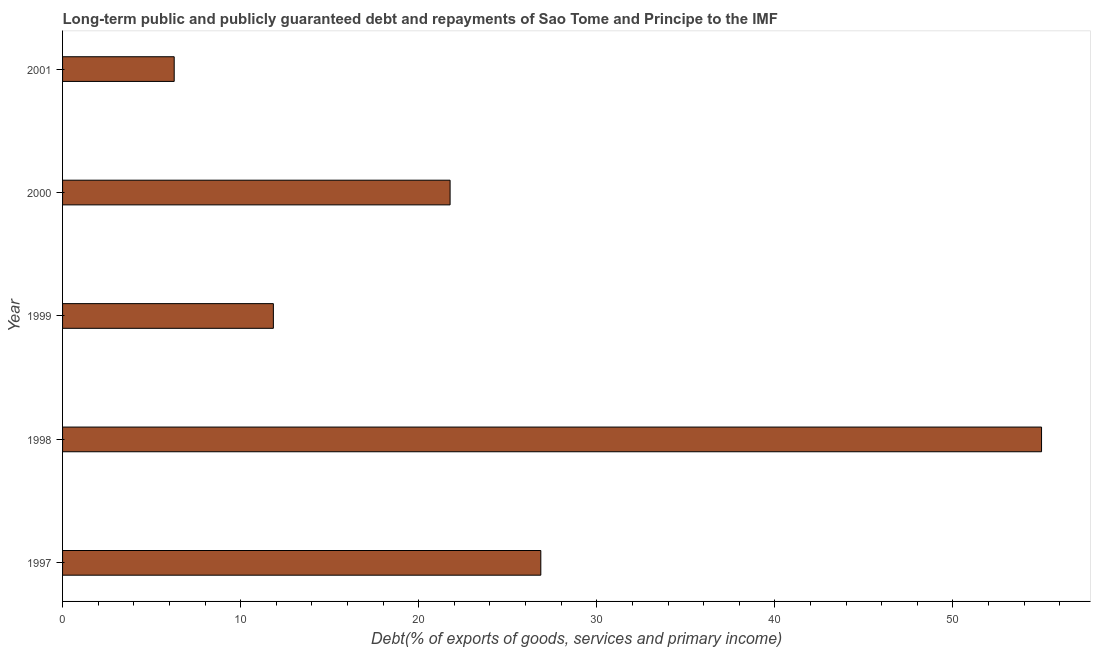Does the graph contain any zero values?
Provide a succinct answer. No. Does the graph contain grids?
Your answer should be compact. No. What is the title of the graph?
Keep it short and to the point. Long-term public and publicly guaranteed debt and repayments of Sao Tome and Principe to the IMF. What is the label or title of the X-axis?
Your answer should be compact. Debt(% of exports of goods, services and primary income). What is the debt service in 1999?
Make the answer very short. 11.84. Across all years, what is the maximum debt service?
Make the answer very short. 54.97. Across all years, what is the minimum debt service?
Your response must be concise. 6.27. In which year was the debt service maximum?
Ensure brevity in your answer.  1998. In which year was the debt service minimum?
Make the answer very short. 2001. What is the sum of the debt service?
Ensure brevity in your answer.  121.7. What is the difference between the debt service in 1997 and 1998?
Keep it short and to the point. -28.12. What is the average debt service per year?
Make the answer very short. 24.34. What is the median debt service?
Offer a very short reply. 21.76. In how many years, is the debt service greater than 34 %?
Provide a short and direct response. 1. Do a majority of the years between 1998 and 2001 (inclusive) have debt service greater than 6 %?
Provide a succinct answer. Yes. What is the ratio of the debt service in 1998 to that in 2001?
Your answer should be very brief. 8.77. What is the difference between the highest and the second highest debt service?
Offer a very short reply. 28.12. Is the sum of the debt service in 1998 and 1999 greater than the maximum debt service across all years?
Offer a terse response. Yes. What is the difference between the highest and the lowest debt service?
Keep it short and to the point. 48.71. In how many years, is the debt service greater than the average debt service taken over all years?
Offer a very short reply. 2. Are all the bars in the graph horizontal?
Your answer should be compact. Yes. How many years are there in the graph?
Give a very brief answer. 5. What is the difference between two consecutive major ticks on the X-axis?
Keep it short and to the point. 10. Are the values on the major ticks of X-axis written in scientific E-notation?
Keep it short and to the point. No. What is the Debt(% of exports of goods, services and primary income) in 1997?
Offer a terse response. 26.86. What is the Debt(% of exports of goods, services and primary income) in 1998?
Provide a short and direct response. 54.97. What is the Debt(% of exports of goods, services and primary income) in 1999?
Your answer should be very brief. 11.84. What is the Debt(% of exports of goods, services and primary income) of 2000?
Give a very brief answer. 21.76. What is the Debt(% of exports of goods, services and primary income) of 2001?
Offer a terse response. 6.27. What is the difference between the Debt(% of exports of goods, services and primary income) in 1997 and 1998?
Your answer should be very brief. -28.12. What is the difference between the Debt(% of exports of goods, services and primary income) in 1997 and 1999?
Offer a very short reply. 15.02. What is the difference between the Debt(% of exports of goods, services and primary income) in 1997 and 2000?
Ensure brevity in your answer.  5.09. What is the difference between the Debt(% of exports of goods, services and primary income) in 1997 and 2001?
Your response must be concise. 20.59. What is the difference between the Debt(% of exports of goods, services and primary income) in 1998 and 1999?
Your answer should be very brief. 43.14. What is the difference between the Debt(% of exports of goods, services and primary income) in 1998 and 2000?
Give a very brief answer. 33.21. What is the difference between the Debt(% of exports of goods, services and primary income) in 1998 and 2001?
Ensure brevity in your answer.  48.71. What is the difference between the Debt(% of exports of goods, services and primary income) in 1999 and 2000?
Give a very brief answer. -9.92. What is the difference between the Debt(% of exports of goods, services and primary income) in 1999 and 2001?
Offer a very short reply. 5.57. What is the difference between the Debt(% of exports of goods, services and primary income) in 2000 and 2001?
Your answer should be very brief. 15.49. What is the ratio of the Debt(% of exports of goods, services and primary income) in 1997 to that in 1998?
Offer a terse response. 0.49. What is the ratio of the Debt(% of exports of goods, services and primary income) in 1997 to that in 1999?
Your answer should be very brief. 2.27. What is the ratio of the Debt(% of exports of goods, services and primary income) in 1997 to that in 2000?
Offer a very short reply. 1.23. What is the ratio of the Debt(% of exports of goods, services and primary income) in 1997 to that in 2001?
Offer a very short reply. 4.28. What is the ratio of the Debt(% of exports of goods, services and primary income) in 1998 to that in 1999?
Your answer should be very brief. 4.64. What is the ratio of the Debt(% of exports of goods, services and primary income) in 1998 to that in 2000?
Give a very brief answer. 2.53. What is the ratio of the Debt(% of exports of goods, services and primary income) in 1998 to that in 2001?
Your answer should be compact. 8.77. What is the ratio of the Debt(% of exports of goods, services and primary income) in 1999 to that in 2000?
Your answer should be very brief. 0.54. What is the ratio of the Debt(% of exports of goods, services and primary income) in 1999 to that in 2001?
Offer a very short reply. 1.89. What is the ratio of the Debt(% of exports of goods, services and primary income) in 2000 to that in 2001?
Your answer should be very brief. 3.47. 